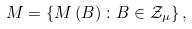Convert formula to latex. <formula><loc_0><loc_0><loc_500><loc_500>M = \left \{ M \left ( B \right ) \colon B \in \mathcal { Z } _ { \mu } \right \} ,</formula> 